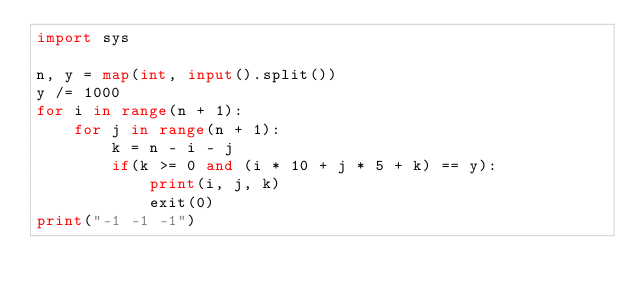Convert code to text. <code><loc_0><loc_0><loc_500><loc_500><_Python_>import sys

n, y = map(int, input().split())
y /= 1000
for i in range(n + 1):
    for j in range(n + 1):
        k = n - i - j
        if(k >= 0 and (i * 10 + j * 5 + k) == y):
            print(i, j, k)
            exit(0)
print("-1 -1 -1")
</code> 